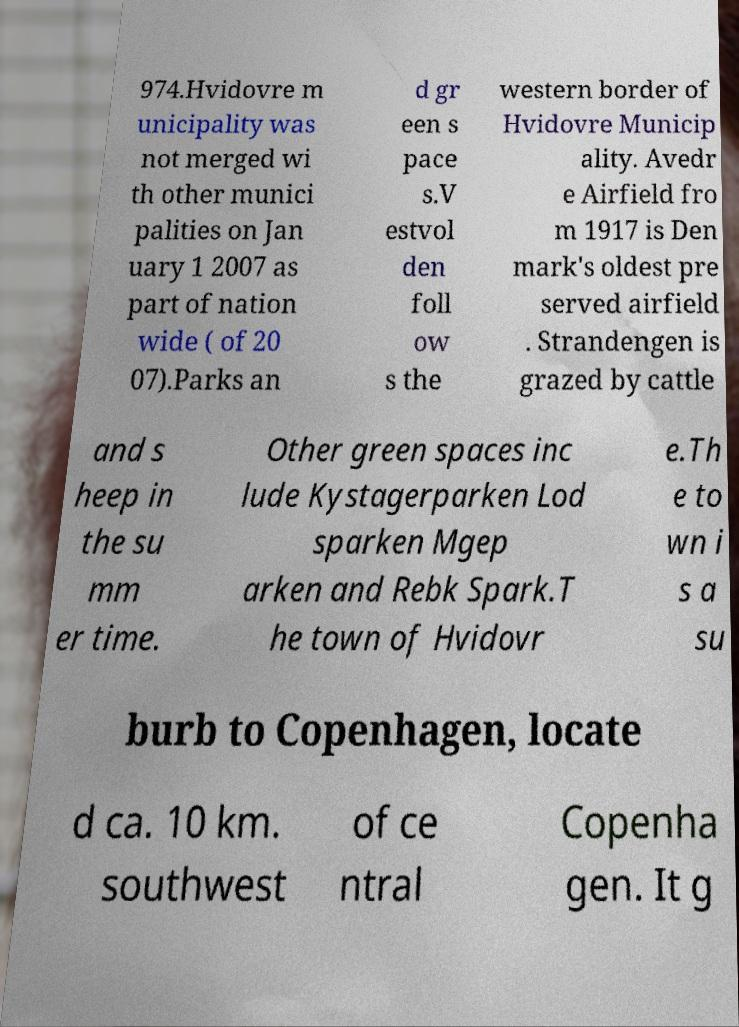There's text embedded in this image that I need extracted. Can you transcribe it verbatim? 974.Hvidovre m unicipality was not merged wi th other munici palities on Jan uary 1 2007 as part of nation wide ( of 20 07).Parks an d gr een s pace s.V estvol den foll ow s the western border of Hvidovre Municip ality. Avedr e Airfield fro m 1917 is Den mark's oldest pre served airfield . Strandengen is grazed by cattle and s heep in the su mm er time. Other green spaces inc lude Kystagerparken Lod sparken Mgep arken and Rebk Spark.T he town of Hvidovr e.Th e to wn i s a su burb to Copenhagen, locate d ca. 10 km. southwest of ce ntral Copenha gen. It g 